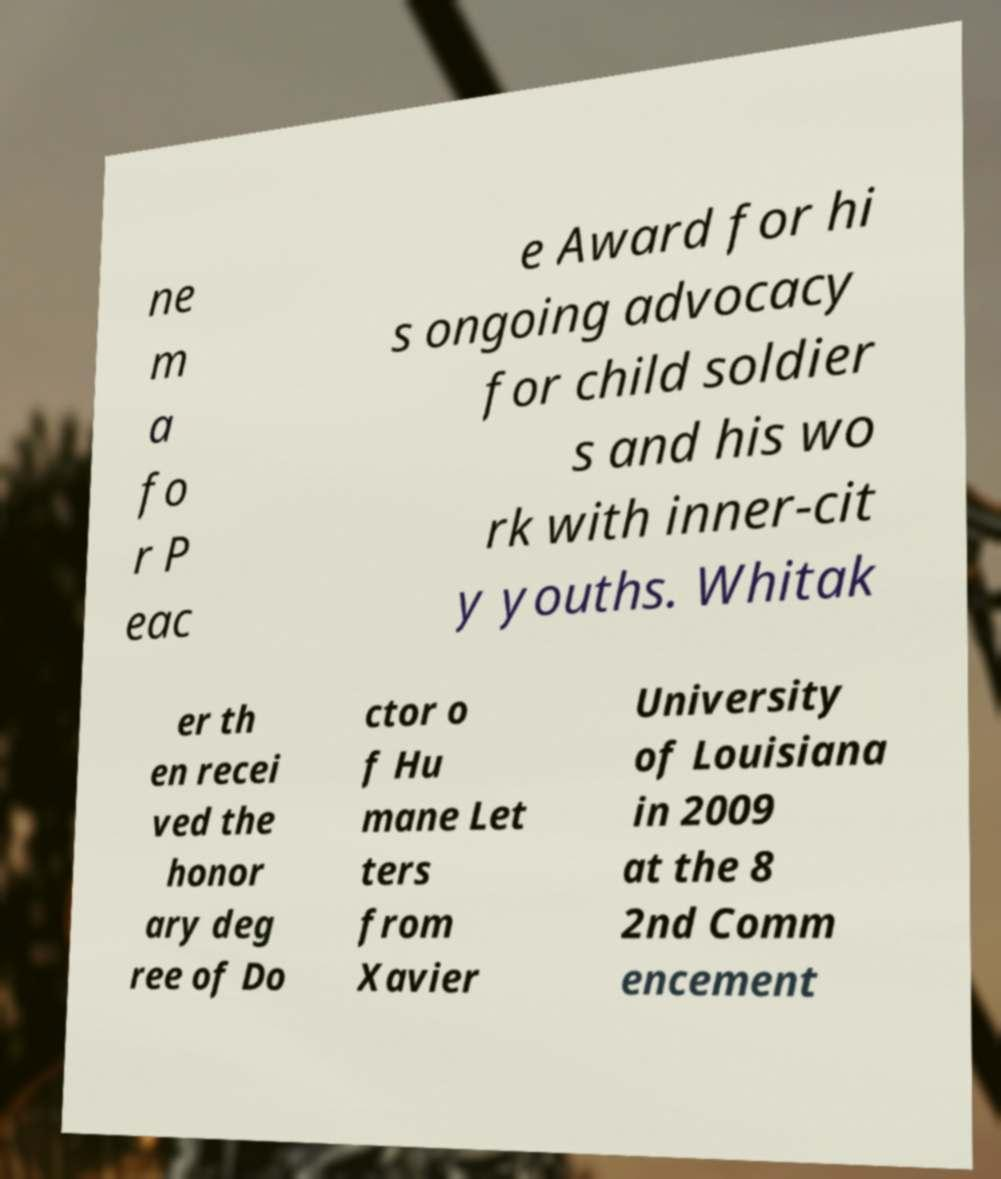Please identify and transcribe the text found in this image. ne m a fo r P eac e Award for hi s ongoing advocacy for child soldier s and his wo rk with inner-cit y youths. Whitak er th en recei ved the honor ary deg ree of Do ctor o f Hu mane Let ters from Xavier University of Louisiana in 2009 at the 8 2nd Comm encement 